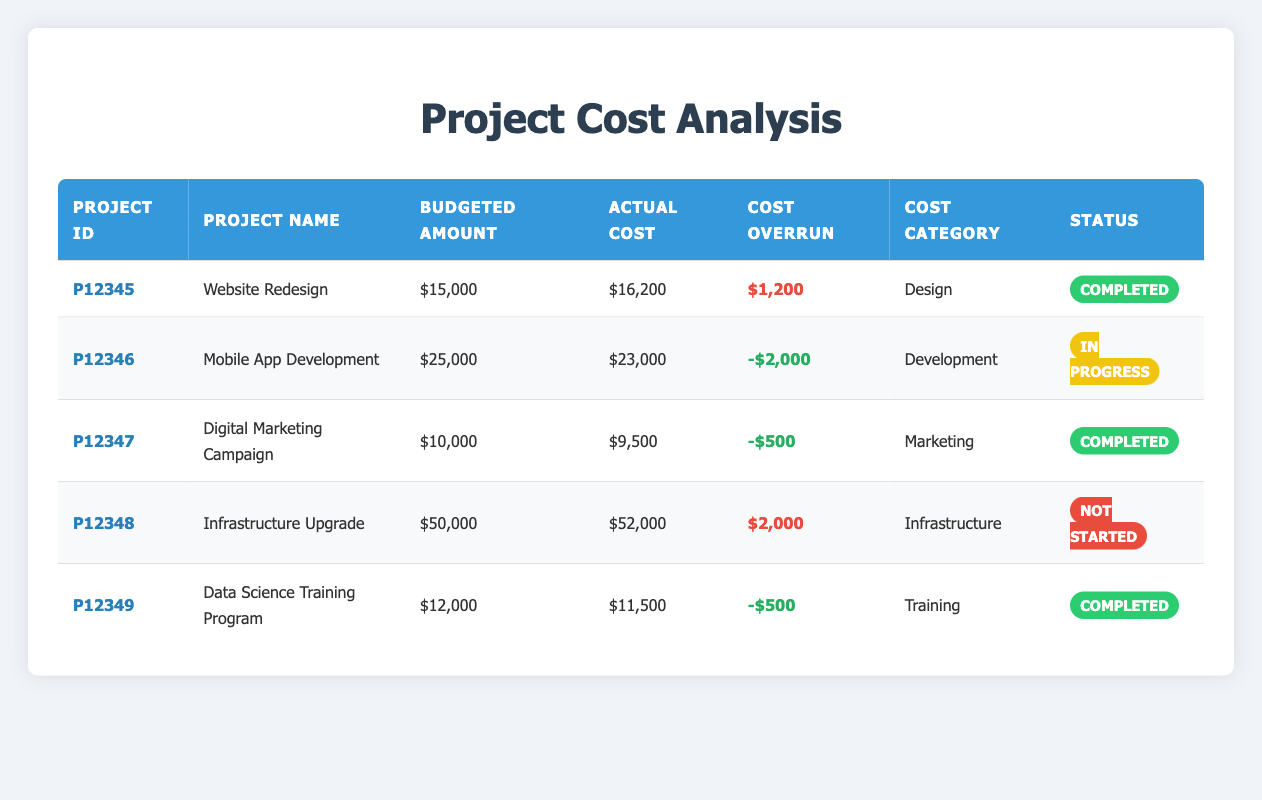What is the actual cost of the "Website Redesign" project? Referring to the table, I locate the row for the "Website Redesign" project and find the value in the "Actual Cost" column, which is $16,200.
Answer: $16,200 How much was the budgeted amount for the "Data Science Training Program"? The "Data Science Training Program" row shows the budgeted amount in the corresponding column, which is $12,000.
Answer: $12,000 Which project has the highest cost overrun? By examining the "Cost Overrun" column, I compare all the values and see that the "Website Redesign" project has the highest cost overrun of $1,200.
Answer: Website Redesign Is the "Digital Marketing Campaign" project completed? Looking at the "Deliverable Status" column for the "Digital Marketing Campaign", the status shows "Completed". Therefore, the answer is yes.
Answer: Yes What is the total budgeted amount for all projects? I sum the values from the "Budgeted Amount" column: $15,000 + $25,000 + $10,000 + $50,000 + $12,000 = $112,000.
Answer: $112,000 How many projects are in progress? I review the "Deliverable Status" column and count the projects with the status "In Progress". There is 1 such project, which is "Mobile App Development".
Answer: 1 Did any project come under budget? I check the "Cost Overrun" column for negative values, indicating a project came under budget. The "Mobile App Development", "Digital Marketing Campaign", and "Data Science Training Program" all show negative amounts, confirming they are under budget.
Answer: Yes Which project category has the highest total actual cost? To determine this, I sum the actual costs by category: Design ($16,200), Development ($23,000), Marketing ($9,500), Infrastructure ($52,000), and Training ($11,500). The sum is $112,200 for Development (actual cost only). The highest total actual cost belongs to Infrastructure.
Answer: Infrastructure What is the average cost overrun for completed projects? Focusing on completed projects, I have the following cost overruns: $1,200 (Website Redesign), -$500 (Digital Marketing Campaign), and -$500 (Data Science Training Program). The average is calculated as (1,200 - 500 - 500) / 3 = $100.
Answer: $100 